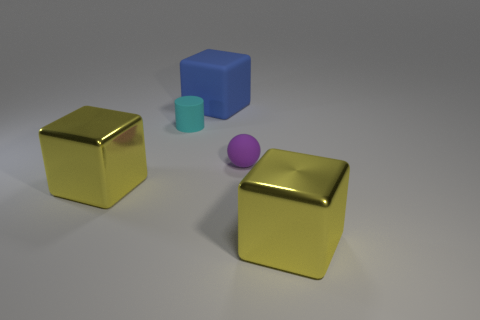How many cylinders are the same size as the purple matte object?
Offer a very short reply. 1. There is a blue rubber thing; does it have the same size as the purple rubber object that is in front of the cylinder?
Give a very brief answer. No. What number of objects are yellow things or big brown shiny blocks?
Offer a terse response. 2. There is a thing that is the same size as the cylinder; what is its shape?
Offer a terse response. Sphere. Is there a yellow metal thing that has the same shape as the blue object?
Your answer should be compact. Yes. What number of yellow things are the same material as the cyan cylinder?
Your response must be concise. 0. Is the material of the tiny cyan thing that is in front of the blue block the same as the big blue object?
Provide a succinct answer. Yes. Is the number of yellow blocks right of the blue rubber cube greater than the number of metallic cubes that are behind the small cyan object?
Offer a very short reply. Yes. There is a cylinder that is the same size as the purple matte ball; what material is it?
Provide a short and direct response. Rubber. What number of other objects are the same material as the cylinder?
Provide a short and direct response. 2. 